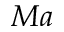<formula> <loc_0><loc_0><loc_500><loc_500>M a</formula> 